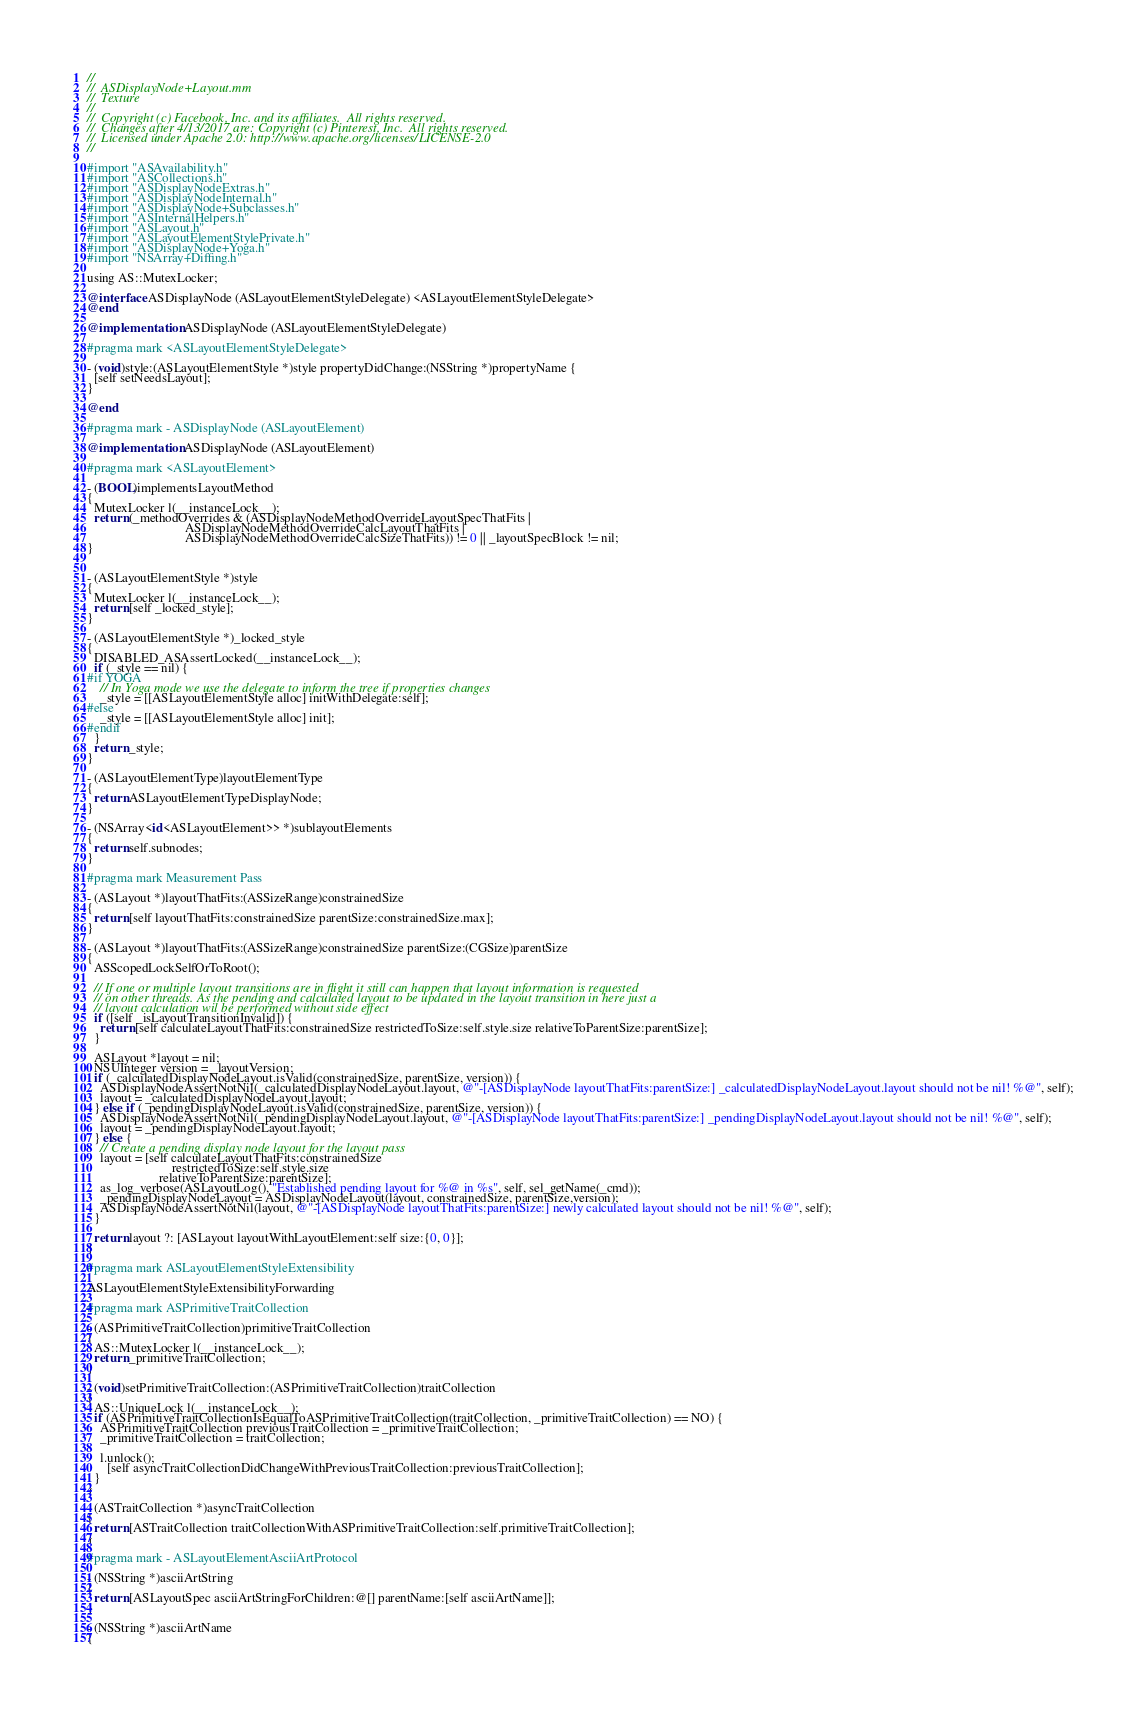<code> <loc_0><loc_0><loc_500><loc_500><_ObjectiveC_>//
//  ASDisplayNode+Layout.mm
//  Texture
//
//  Copyright (c) Facebook, Inc. and its affiliates.  All rights reserved.
//  Changes after 4/13/2017 are: Copyright (c) Pinterest, Inc.  All rights reserved.
//  Licensed under Apache 2.0: http://www.apache.org/licenses/LICENSE-2.0
//

#import "ASAvailability.h"
#import "ASCollections.h"
#import "ASDisplayNodeExtras.h"
#import "ASDisplayNodeInternal.h"
#import "ASDisplayNode+Subclasses.h"
#import "ASInternalHelpers.h"
#import "ASLayout.h"
#import "ASLayoutElementStylePrivate.h"
#import "ASDisplayNode+Yoga.h"
#import "NSArray+Diffing.h"

using AS::MutexLocker;

@interface ASDisplayNode (ASLayoutElementStyleDelegate) <ASLayoutElementStyleDelegate>
@end

@implementation ASDisplayNode (ASLayoutElementStyleDelegate)

#pragma mark <ASLayoutElementStyleDelegate>

- (void)style:(ASLayoutElementStyle *)style propertyDidChange:(NSString *)propertyName {
  [self setNeedsLayout];
}

@end

#pragma mark - ASDisplayNode (ASLayoutElement)

@implementation ASDisplayNode (ASLayoutElement)

#pragma mark <ASLayoutElement>

- (BOOL)implementsLayoutMethod
{
  MutexLocker l(__instanceLock__);
  return (_methodOverrides & (ASDisplayNodeMethodOverrideLayoutSpecThatFits |
                              ASDisplayNodeMethodOverrideCalcLayoutThatFits |
                              ASDisplayNodeMethodOverrideCalcSizeThatFits)) != 0 || _layoutSpecBlock != nil;
}


- (ASLayoutElementStyle *)style
{
  MutexLocker l(__instanceLock__);
  return [self _locked_style];
}

- (ASLayoutElementStyle *)_locked_style
{
  DISABLED_ASAssertLocked(__instanceLock__);
  if (_style == nil) {
#if YOGA
    // In Yoga mode we use the delegate to inform the tree if properties changes
    _style = [[ASLayoutElementStyle alloc] initWithDelegate:self];
#else
    _style = [[ASLayoutElementStyle alloc] init];
#endif
  }
  return _style;
}

- (ASLayoutElementType)layoutElementType
{
  return ASLayoutElementTypeDisplayNode;
}

- (NSArray<id<ASLayoutElement>> *)sublayoutElements
{
  return self.subnodes;
}

#pragma mark Measurement Pass

- (ASLayout *)layoutThatFits:(ASSizeRange)constrainedSize
{
  return [self layoutThatFits:constrainedSize parentSize:constrainedSize.max];
}

- (ASLayout *)layoutThatFits:(ASSizeRange)constrainedSize parentSize:(CGSize)parentSize
{
  ASScopedLockSelfOrToRoot();

  // If one or multiple layout transitions are in flight it still can happen that layout information is requested
  // on other threads. As the pending and calculated layout to be updated in the layout transition in here just a
  // layout calculation wil be performed without side effect
  if ([self _isLayoutTransitionInvalid]) {
    return [self calculateLayoutThatFits:constrainedSize restrictedToSize:self.style.size relativeToParentSize:parentSize];
  }

  ASLayout *layout = nil;
  NSUInteger version = _layoutVersion;
  if (_calculatedDisplayNodeLayout.isValid(constrainedSize, parentSize, version)) {
    ASDisplayNodeAssertNotNil(_calculatedDisplayNodeLayout.layout, @"-[ASDisplayNode layoutThatFits:parentSize:] _calculatedDisplayNodeLayout.layout should not be nil! %@", self);
    layout = _calculatedDisplayNodeLayout.layout;
  } else if (_pendingDisplayNodeLayout.isValid(constrainedSize, parentSize, version)) {
    ASDisplayNodeAssertNotNil(_pendingDisplayNodeLayout.layout, @"-[ASDisplayNode layoutThatFits:parentSize:] _pendingDisplayNodeLayout.layout should not be nil! %@", self);
    layout = _pendingDisplayNodeLayout.layout;
  } else {
    // Create a pending display node layout for the layout pass
    layout = [self calculateLayoutThatFits:constrainedSize
                          restrictedToSize:self.style.size
                      relativeToParentSize:parentSize];
    as_log_verbose(ASLayoutLog(), "Established pending layout for %@ in %s", self, sel_getName(_cmd));
    _pendingDisplayNodeLayout = ASDisplayNodeLayout(layout, constrainedSize, parentSize,version);
    ASDisplayNodeAssertNotNil(layout, @"-[ASDisplayNode layoutThatFits:parentSize:] newly calculated layout should not be nil! %@", self);
  }
  
  return layout ?: [ASLayout layoutWithLayoutElement:self size:{0, 0}];
}

#pragma mark ASLayoutElementStyleExtensibility

ASLayoutElementStyleExtensibilityForwarding

#pragma mark ASPrimitiveTraitCollection

- (ASPrimitiveTraitCollection)primitiveTraitCollection
{
  AS::MutexLocker l(__instanceLock__);
  return _primitiveTraitCollection;
}

- (void)setPrimitiveTraitCollection:(ASPrimitiveTraitCollection)traitCollection
{
  AS::UniqueLock l(__instanceLock__);
  if (ASPrimitiveTraitCollectionIsEqualToASPrimitiveTraitCollection(traitCollection, _primitiveTraitCollection) == NO) {
    ASPrimitiveTraitCollection previousTraitCollection = _primitiveTraitCollection;
    _primitiveTraitCollection = traitCollection;

    l.unlock();
      [self asyncTraitCollectionDidChangeWithPreviousTraitCollection:previousTraitCollection];
  }
}

- (ASTraitCollection *)asyncTraitCollection
{
  return [ASTraitCollection traitCollectionWithASPrimitiveTraitCollection:self.primitiveTraitCollection];
}

#pragma mark - ASLayoutElementAsciiArtProtocol

- (NSString *)asciiArtString
{
  return [ASLayoutSpec asciiArtStringForChildren:@[] parentName:[self asciiArtName]];
}

- (NSString *)asciiArtName
{</code> 